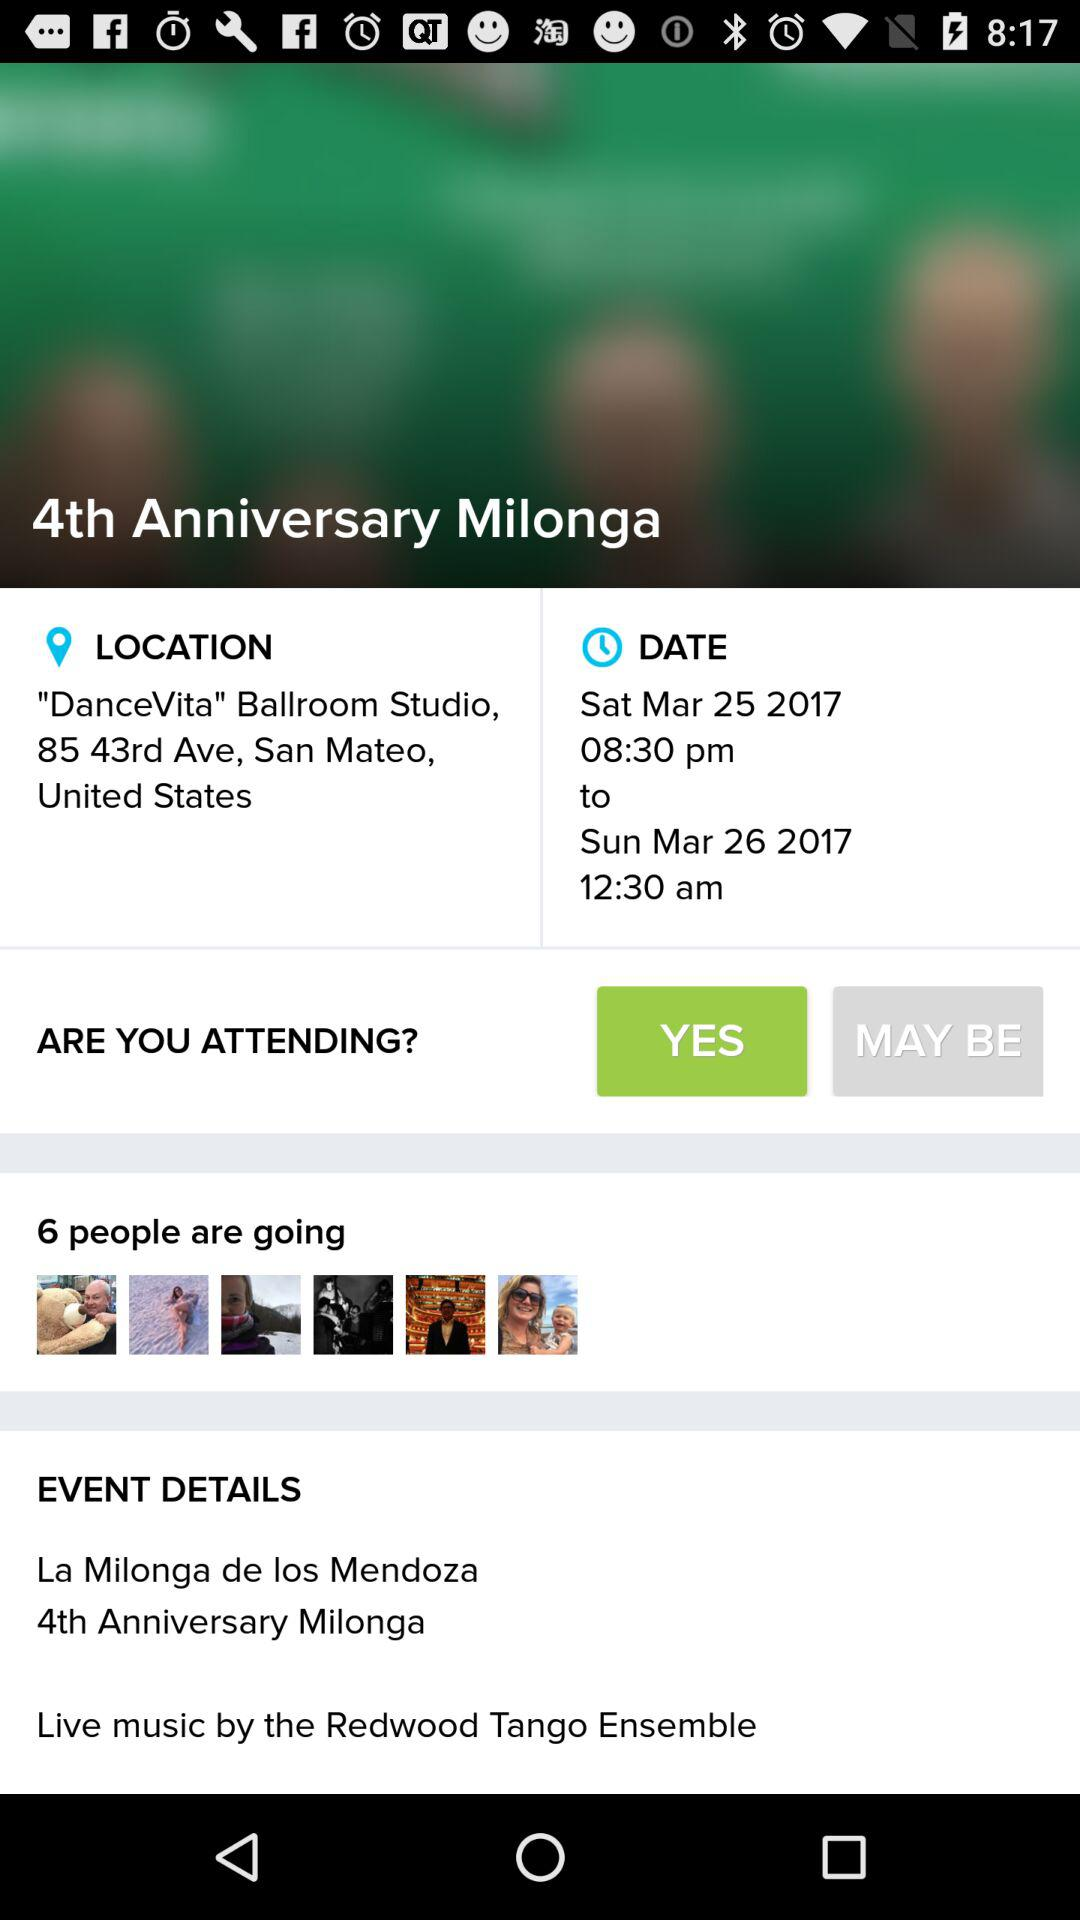How can we join the "Rancho Solano Spring Fling Boutique" event? You can join the event by logging in with "Facebook". 